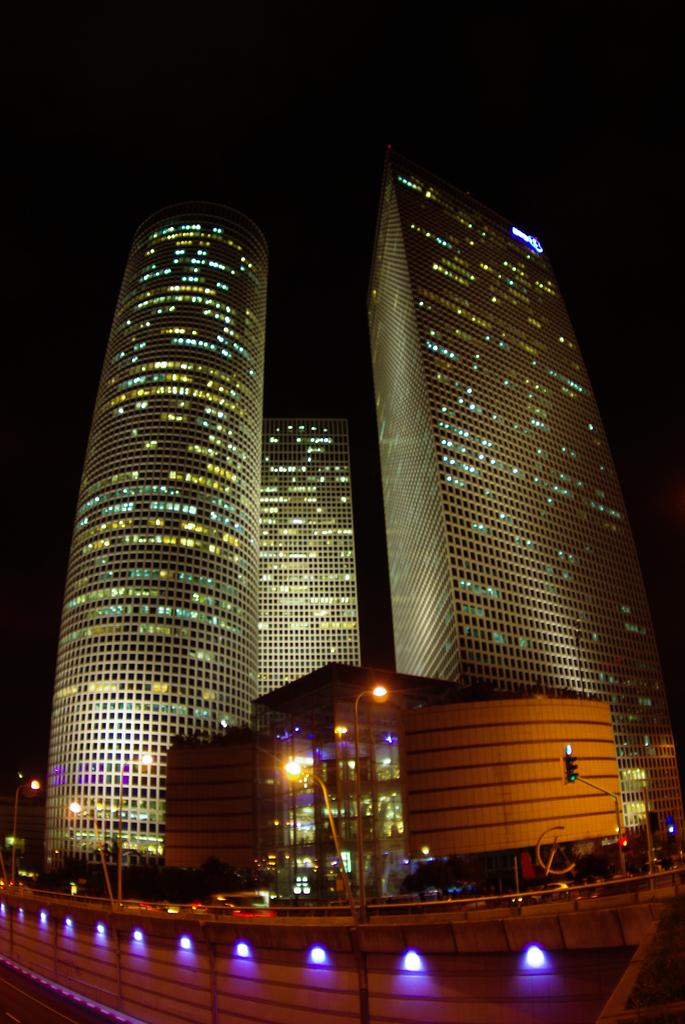What type of structures can be seen in the image? There are buildings in the image. What helps regulate traffic in the image? There are traffic lights in the image. What provides illumination in the image? There are pole lights in the image. What separates the area in the image? There is a fence in the image. What is moving on the road in the image? There are vehicles on the road in the image. What can be seen in the distance in the image? The sky is visible in the background of the image, and there are other objects visible as well. How many trees are visible in the image? There are no trees visible in the image. What type of hat is the pole light wearing in the image? There are no hats present in the image, as pole lights are not capable of wearing hats. 